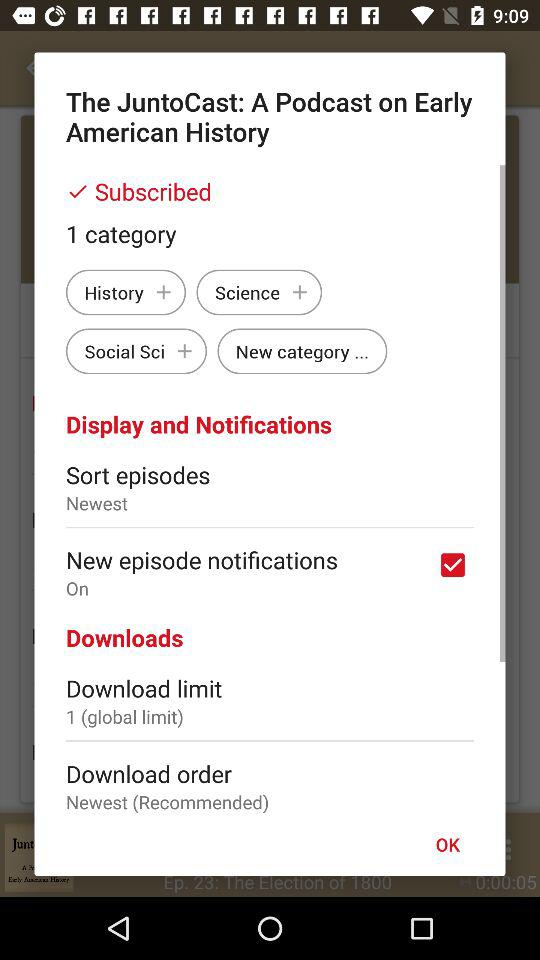How many categories are there? There is 1 category. 